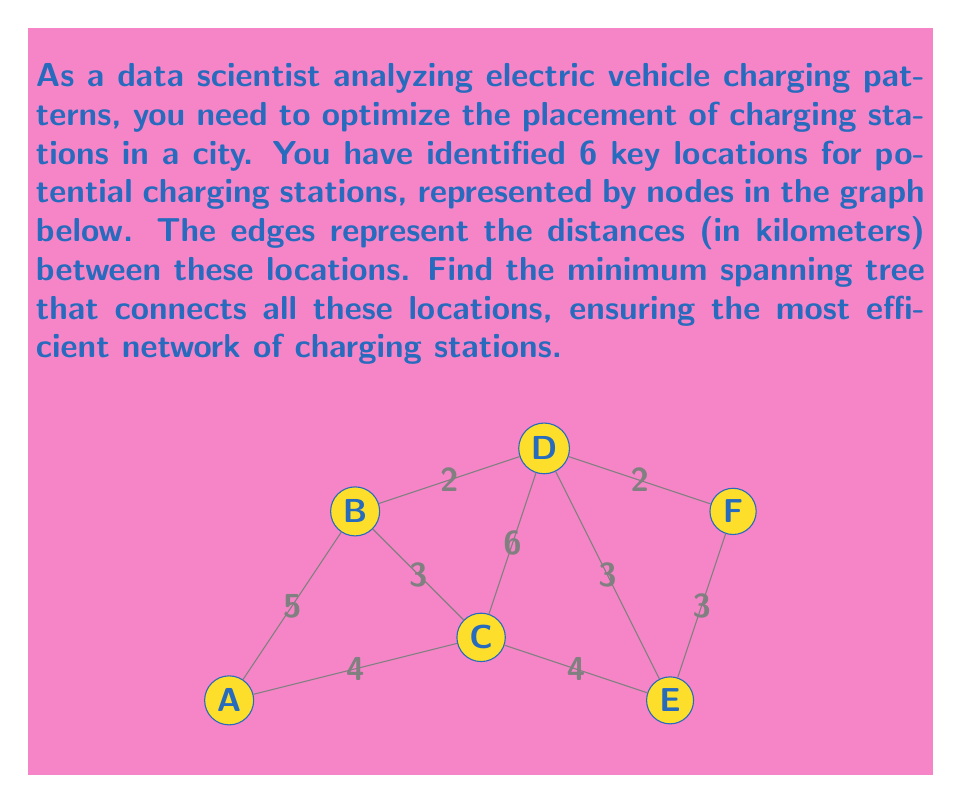Solve this math problem. To find the minimum spanning tree, we can use Kruskal's algorithm:

1) Sort all edges by weight (distance):
   B-D (2), D-F (2), B-C (3), D-E (3), E-F (3), A-C (4), C-E (4), A-B (5), C-D (6)

2) Start with an empty graph and add edges in order, skipping those that would create a cycle:

   a) Add B-D (2)
   b) Add D-F (2)
   c) Add B-C (3)
   d) Add D-E (3)
   e) Add A-C (4) to connect the last node

3) The resulting minimum spanning tree has edges:
   B-D, D-F, B-C, D-E, A-C

4) Calculate the total distance:
   $$2 + 2 + 3 + 3 + 4 = 14 \text{ km}$$

This minimum spanning tree connects all locations with the shortest total distance, optimizing the charging station network.
Answer: Minimum spanning tree: A-C-B-D-E, D-F; Total distance: 14 km 